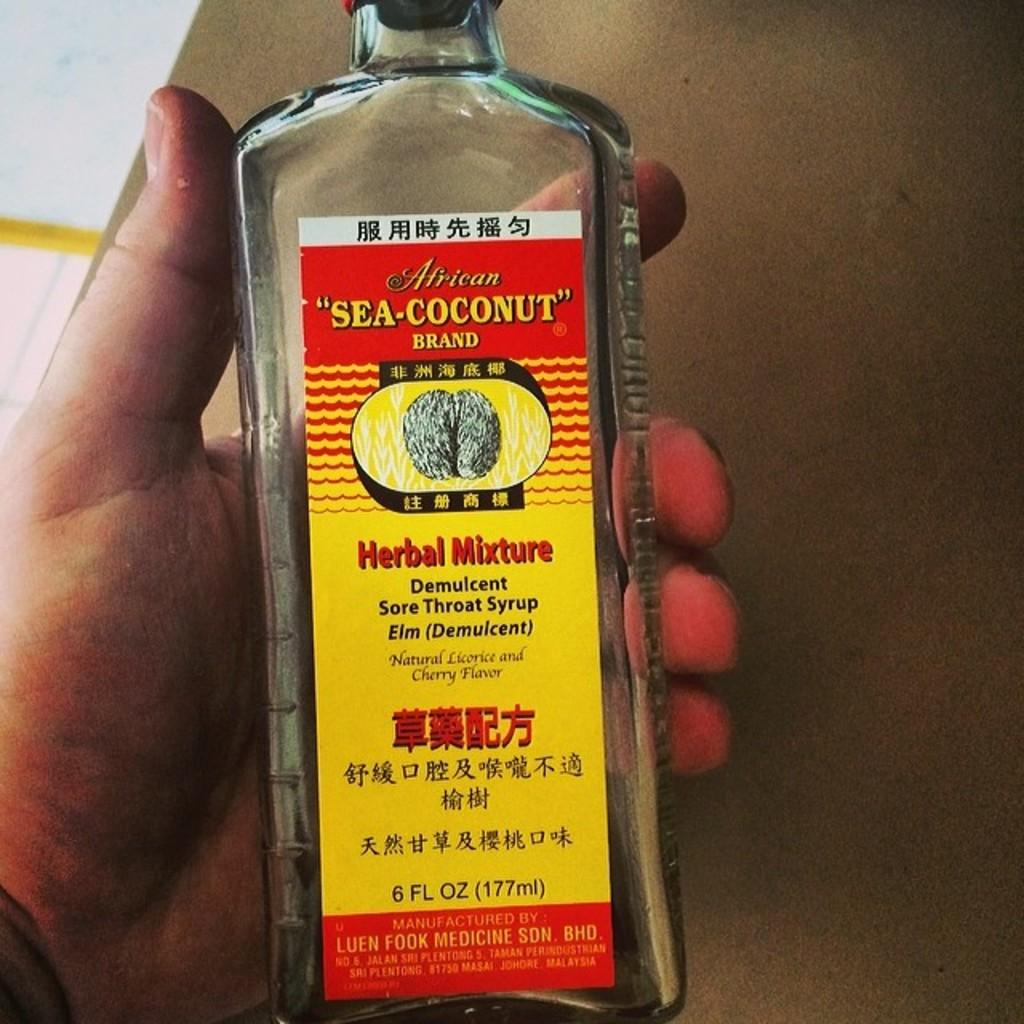Provide a one-sentence caption for the provided image. The label on a bottle claims to be a herbal mixture sore throat syrup. 